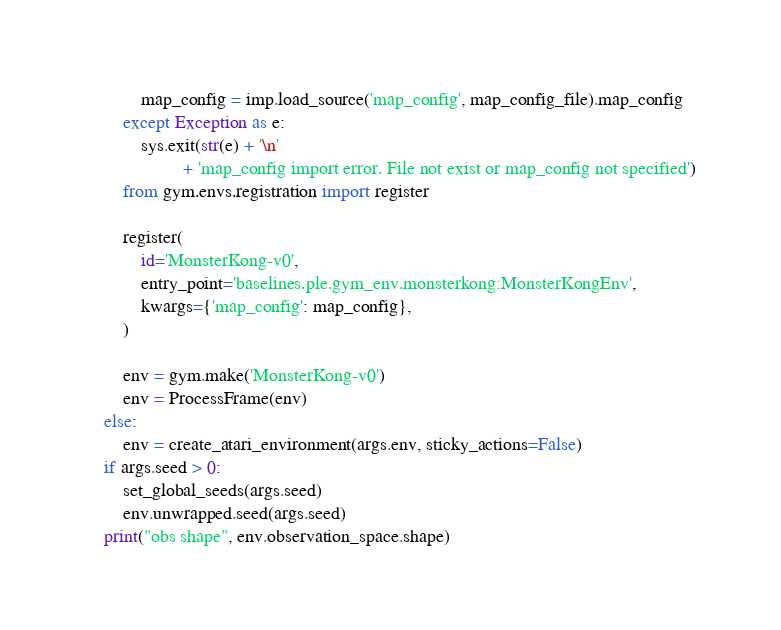<code> <loc_0><loc_0><loc_500><loc_500><_Python_>            map_config = imp.load_source('map_config', map_config_file).map_config
        except Exception as e:
            sys.exit(str(e) + '\n'
                     + 'map_config import error. File not exist or map_config not specified')
        from gym.envs.registration import register

        register(
            id='MonsterKong-v0',
            entry_point='baselines.ple.gym_env.monsterkong:MonsterKongEnv',
            kwargs={'map_config': map_config},
        )

        env = gym.make('MonsterKong-v0')
        env = ProcessFrame(env)
    else:
        env = create_atari_environment(args.env, sticky_actions=False)
    if args.seed > 0:
        set_global_seeds(args.seed)
        env.unwrapped.seed(args.seed)
    print("obs shape", env.observation_space.shape)</code> 